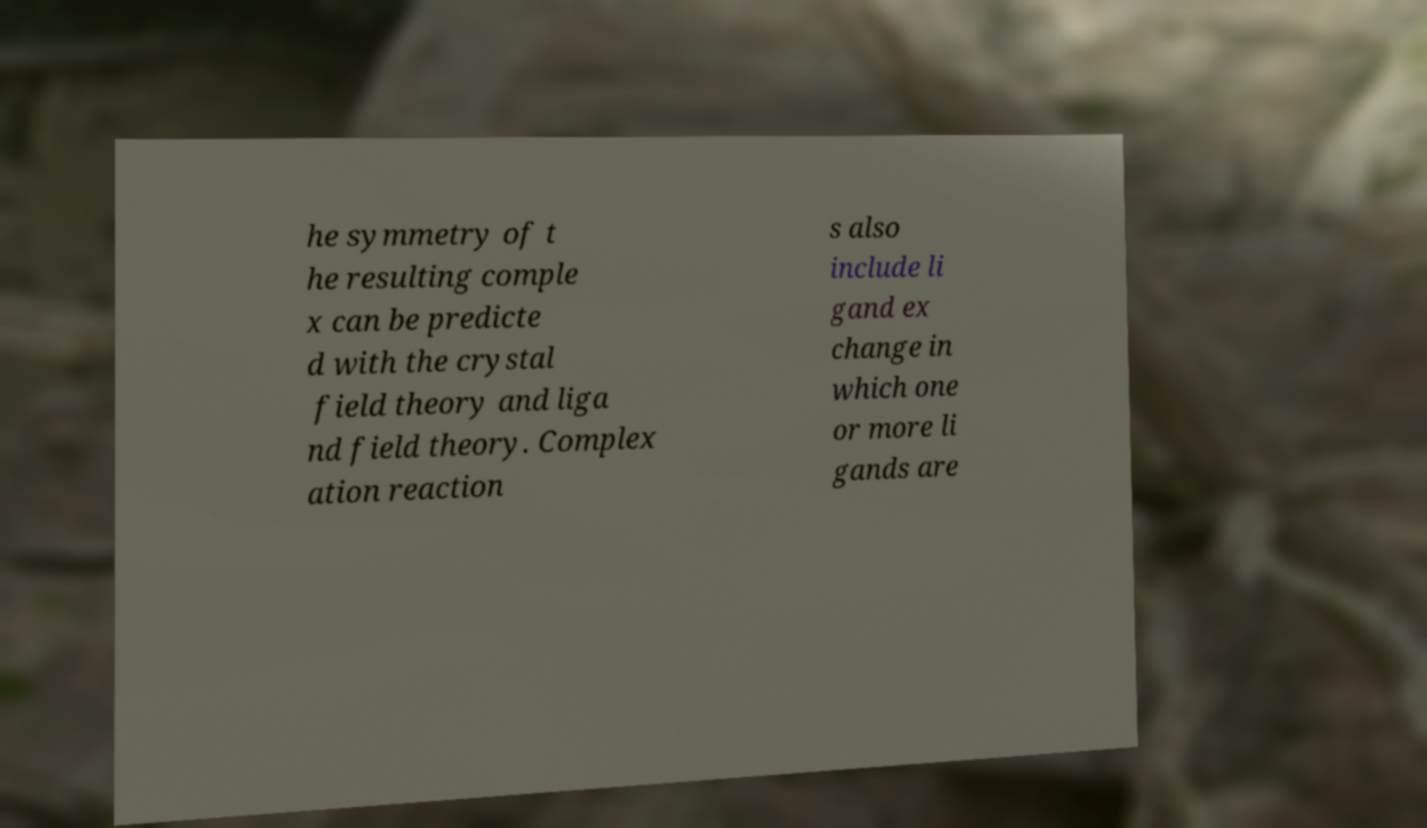There's text embedded in this image that I need extracted. Can you transcribe it verbatim? he symmetry of t he resulting comple x can be predicte d with the crystal field theory and liga nd field theory. Complex ation reaction s also include li gand ex change in which one or more li gands are 